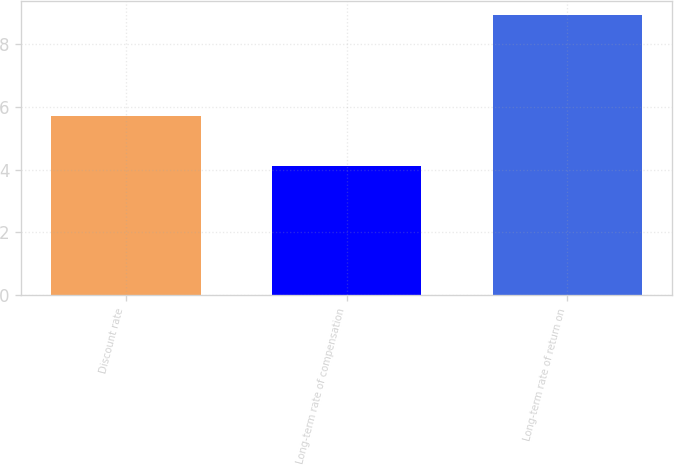Convert chart. <chart><loc_0><loc_0><loc_500><loc_500><bar_chart><fcel>Discount rate<fcel>Long-term rate of compensation<fcel>Long-term rate of return on<nl><fcel>5.7<fcel>4.1<fcel>8.9<nl></chart> 